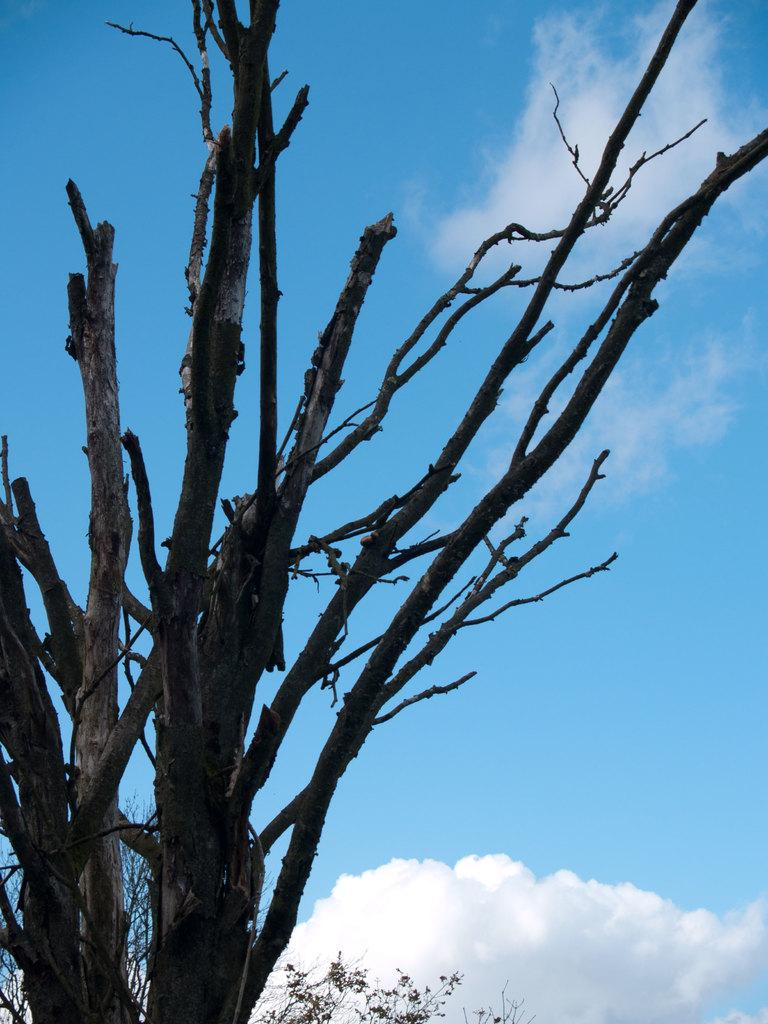What type of vegetation can be seen in the image? There are branches of a tree in the image. What can be seen in the sky in the image? There are clouds visible in the sky. What type of butter is being used to weigh the scale in the image? There is no butter or scale present in the image. Can you describe the flight of the birds in the image? There are no birds present in the image. 